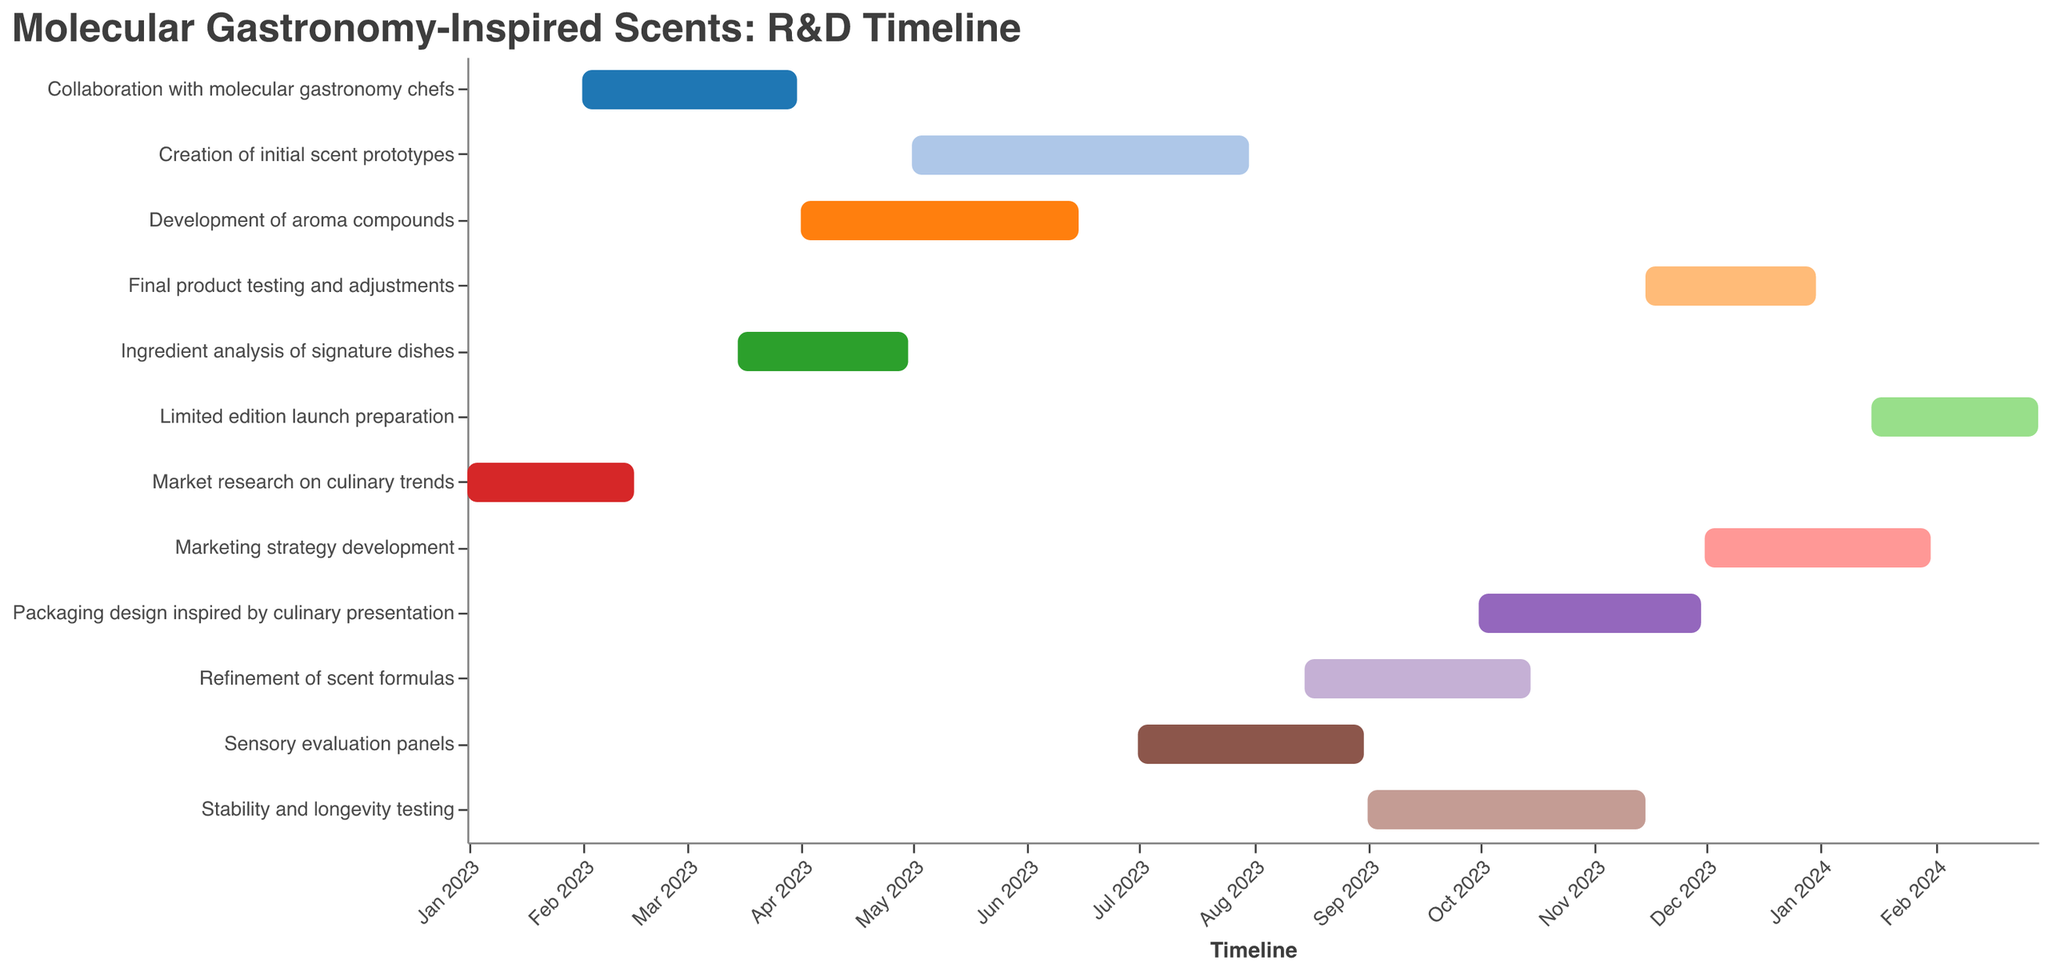What is the title of the Gantt chart? The title is typically located at the top of the chart and is meant to provide an overview or general description of the content of the chart. In this case, it directly states the content being shown.
Answer: Molecular Gastronomy-Inspired Scents: R&D Timeline How many tasks are included in the R&D timeline? Each task is represented as a separate bar in the Gantt chart. By counting these bars, you can determine the total number of tasks included.
Answer: 12 What task starts first according to the timeline? The start date of each task is plotted along the x-axis. By looking at the start dates, the task that starts first can be identified.
Answer: Market research on culinary trends Which task extends the longest duration? By comparing the length of the bars (representing each task's duration) along the x-axis, the task with the longest duration can be identified.
Answer: Creation of initial scent prototypes Which two tasks overlap in their timeframes during March 2023? To determine overlapping tasks, you need to look at the start and end dates of each task. Tasks that have overlapping dates during March 2023 will be concurrent.
Answer: Collaboration with molecular gastronomy chefs and Ingredient analysis of signature dishes Which task ends in December 2023? By looking at the end dates along the x-axis, you can identify which task concludes in December 2023.
Answer: Final product testing and adjustments When does the sensory evaluation panels task start and end? The sensory evaluation panels task's start and end dates will be plotted on the x-axis in the chart. You need to find the bar labeled "Sensory evaluation panels" and note its start and end points.
Answer: Starts July 1, 2023, and ends August 31, 2023 Which task follows immediately after the development of aroma compounds? By looking at the sequential order of tasks and their start dates, you can determine which task begins immediately after another ends. In this case, find the task that begins after the end date of the development of aroma compounds.
Answer: Creation of initial scent prototypes How many tasks continue into October 2023? For each task, check if its duration (as represented by the bar) includes October 2023. Count all such tasks to find the total number.
Answer: 3 What are the start and end dates for the Limited edition launch preparation phase? The start and end dates are typically annotated at both ends of the bar representing each task. Identify the bar for the Limited edition launch preparation and note its dates.
Answer: Starts January 15, 2024, and ends February 29, 2024 